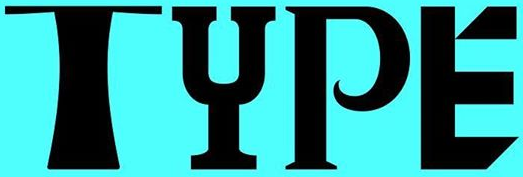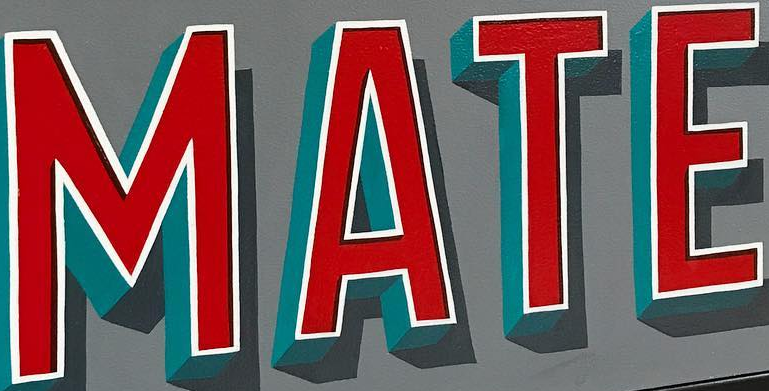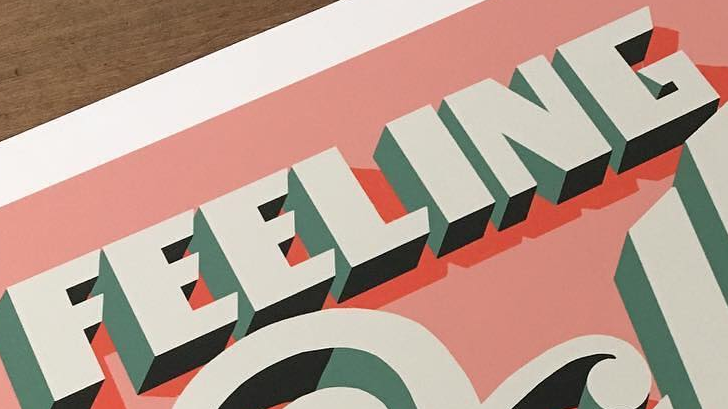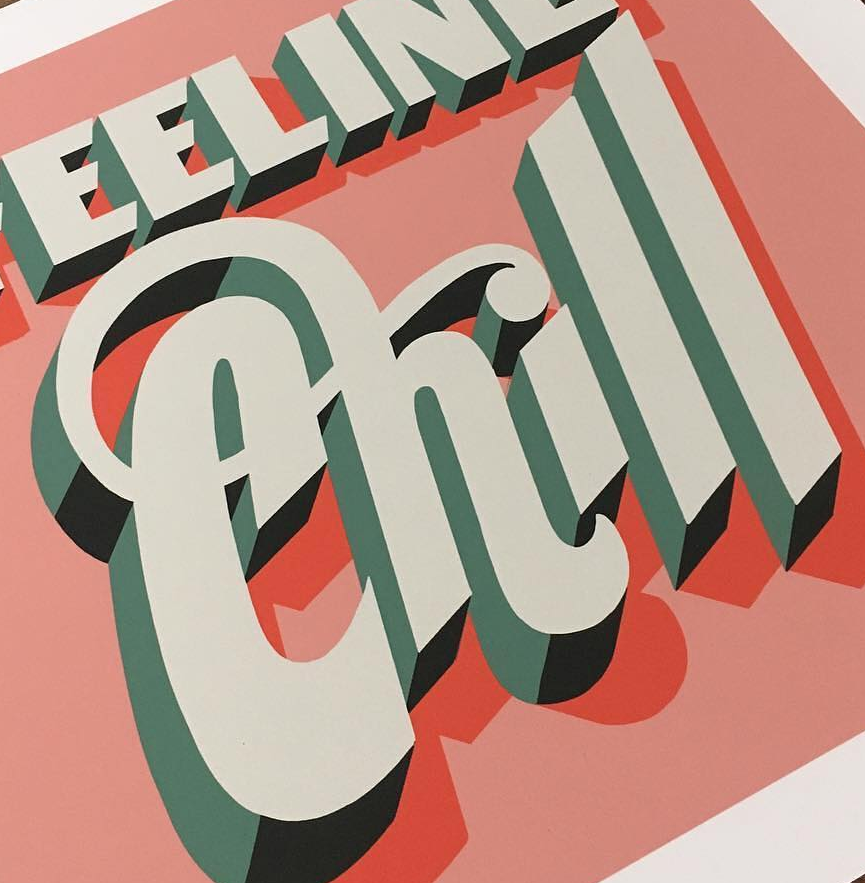What text is displayed in these images sequentially, separated by a semicolon? TYPE; MATE; FEELING; Chill 